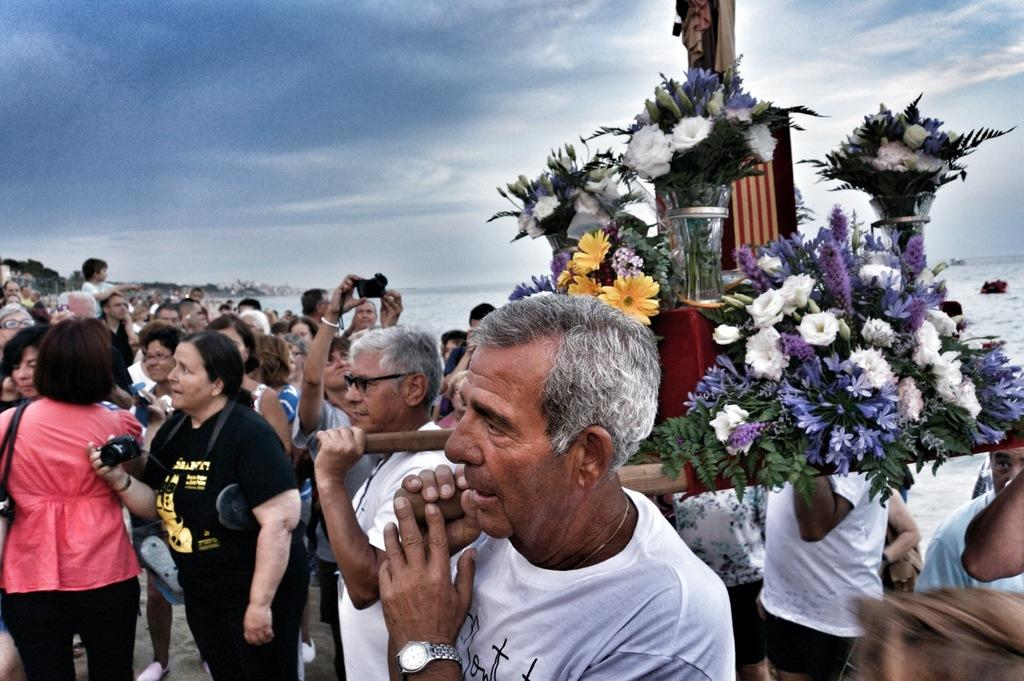What are the people carrying in the image? The people are carrying wooden objects with flower bouquets attached to them in the image. What else can be seen in the hands of the people in the image? Some people are holding cameras and others are holding water. What is visible in the background of the image? The sky is visible in the image. Where is the hose located in the image? There is no hose present in the image. What type of boot is being worn by the people in the image? There is no mention of boots or footwear in the image. 